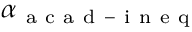Convert formula to latex. <formula><loc_0><loc_0><loc_500><loc_500>\alpha _ { a c a d - i n e q }</formula> 